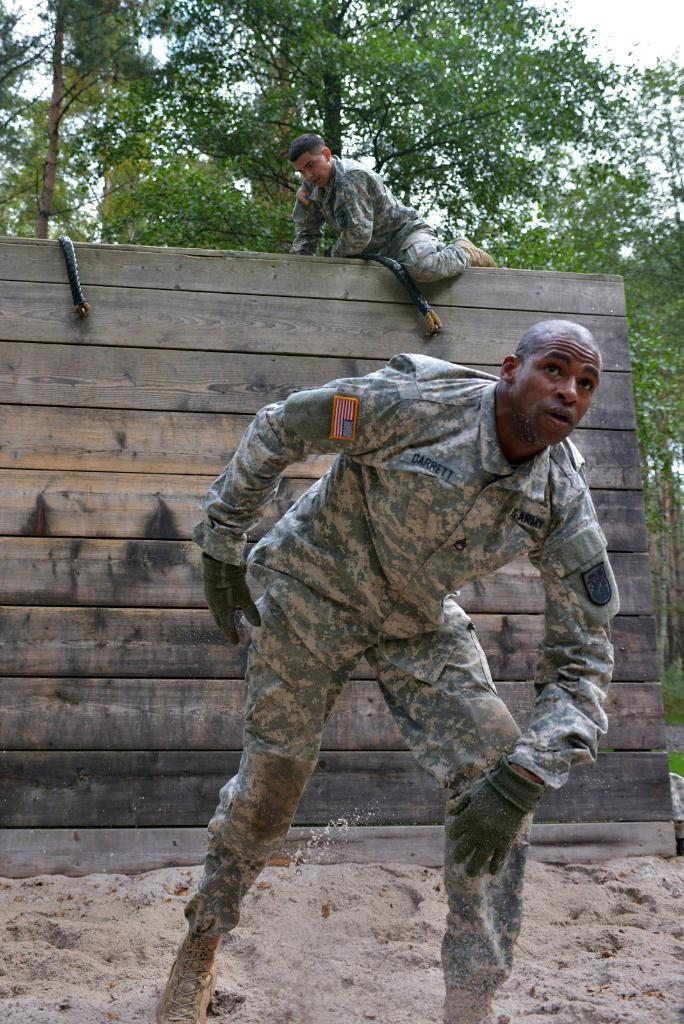How many people are in the image? There are two persons in the image. What is one person doing in the image? One person is climbing a wooden wall. What type of vegetation can be seen in the image? There are trees in the image. What type of terrain is present in the image? There is sand in the image. What is visible in the background of the image? The sky is visible in the image. Can you tell me how many geese are in the bedroom in the image? There is no bedroom or geese present in the image. 